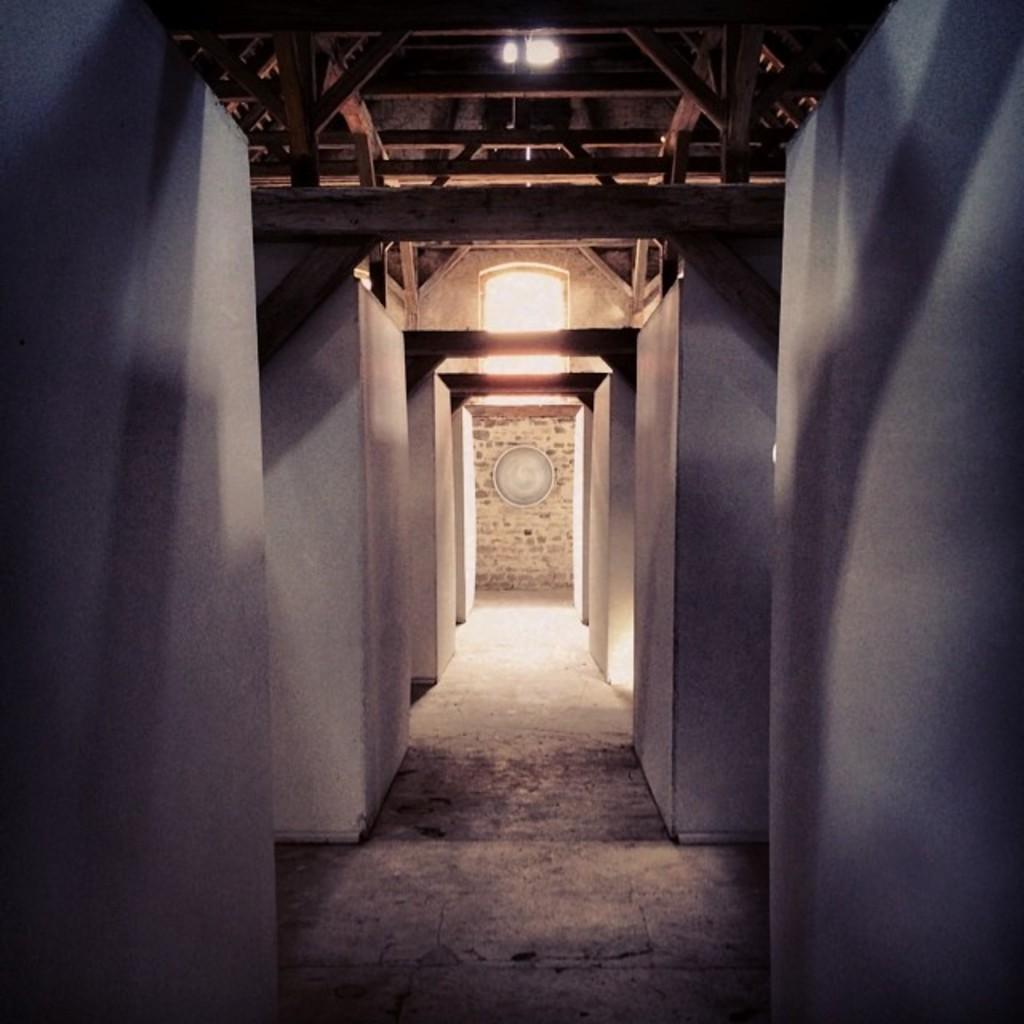What type of view is shown in the image? The image shows an inner view of a building. Can you describe any specific features of the building's interior? The only specific feature mentioned is the presence of lights visible in the image. How far away is the grass from the building in the image? There is no grass visible in the image, as it shows an inner view of a building. 